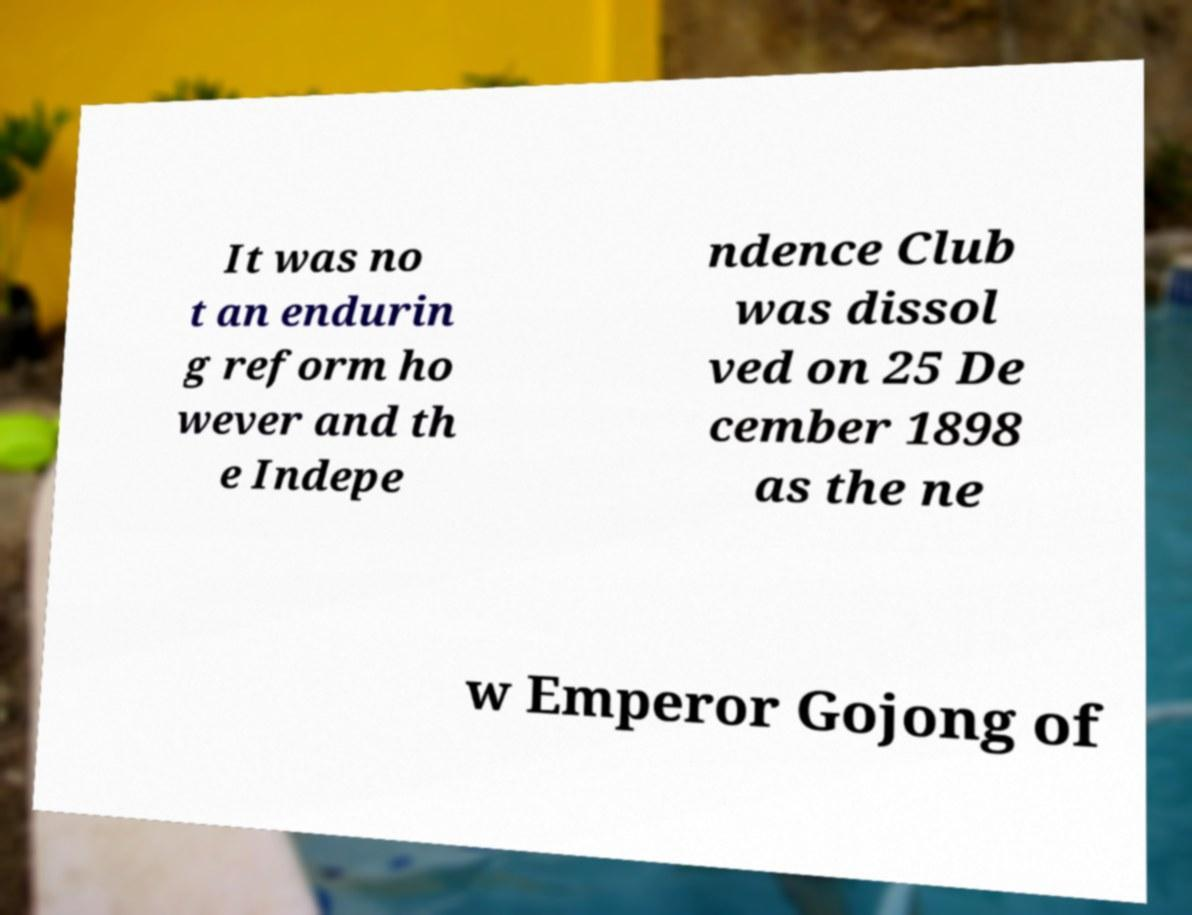For documentation purposes, I need the text within this image transcribed. Could you provide that? It was no t an endurin g reform ho wever and th e Indepe ndence Club was dissol ved on 25 De cember 1898 as the ne w Emperor Gojong of 